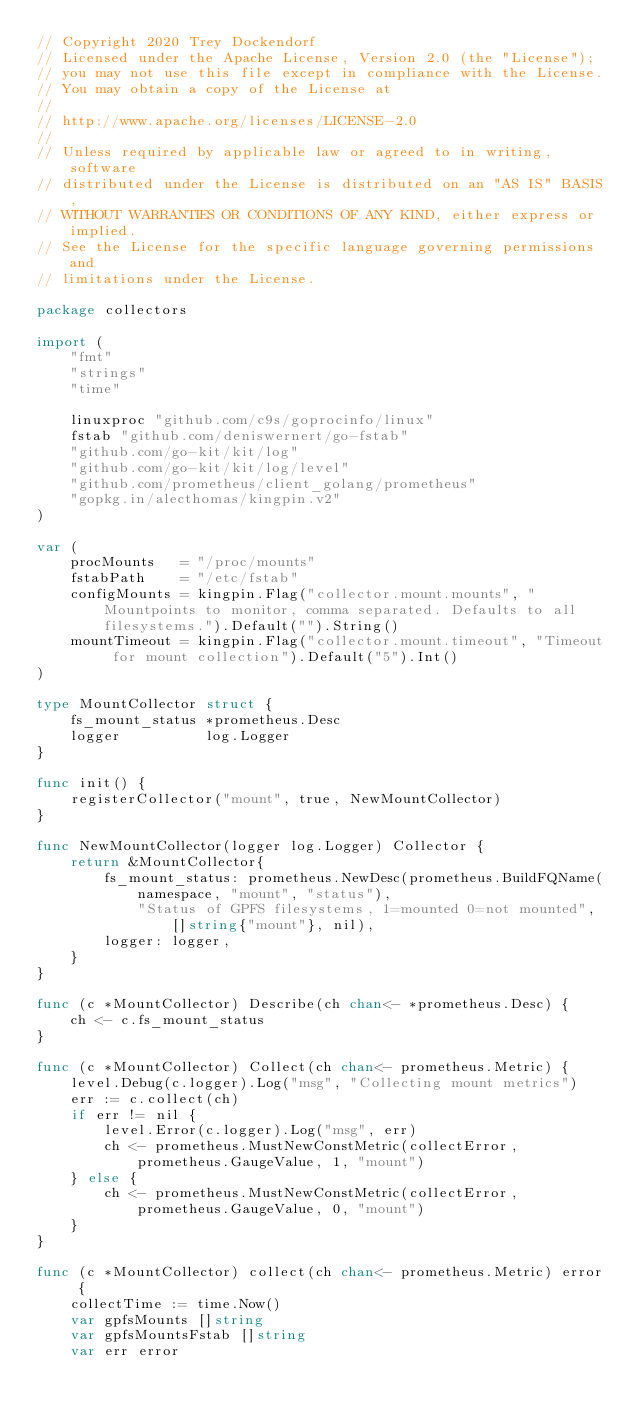Convert code to text. <code><loc_0><loc_0><loc_500><loc_500><_Go_>// Copyright 2020 Trey Dockendorf
// Licensed under the Apache License, Version 2.0 (the "License");
// you may not use this file except in compliance with the License.
// You may obtain a copy of the License at
//
// http://www.apache.org/licenses/LICENSE-2.0
//
// Unless required by applicable law or agreed to in writing, software
// distributed under the License is distributed on an "AS IS" BASIS,
// WITHOUT WARRANTIES OR CONDITIONS OF ANY KIND, either express or implied.
// See the License for the specific language governing permissions and
// limitations under the License.

package collectors

import (
	"fmt"
	"strings"
	"time"

	linuxproc "github.com/c9s/goprocinfo/linux"
	fstab "github.com/deniswernert/go-fstab"
	"github.com/go-kit/kit/log"
	"github.com/go-kit/kit/log/level"
	"github.com/prometheus/client_golang/prometheus"
	"gopkg.in/alecthomas/kingpin.v2"
)

var (
	procMounts   = "/proc/mounts"
	fstabPath    = "/etc/fstab"
	configMounts = kingpin.Flag("collector.mount.mounts", "Mountpoints to monitor, comma separated. Defaults to all filesystems.").Default("").String()
	mountTimeout = kingpin.Flag("collector.mount.timeout", "Timeout for mount collection").Default("5").Int()
)

type MountCollector struct {
	fs_mount_status *prometheus.Desc
	logger          log.Logger
}

func init() {
	registerCollector("mount", true, NewMountCollector)
}

func NewMountCollector(logger log.Logger) Collector {
	return &MountCollector{
		fs_mount_status: prometheus.NewDesc(prometheus.BuildFQName(namespace, "mount", "status"),
			"Status of GPFS filesystems, 1=mounted 0=not mounted", []string{"mount"}, nil),
		logger: logger,
	}
}

func (c *MountCollector) Describe(ch chan<- *prometheus.Desc) {
	ch <- c.fs_mount_status
}

func (c *MountCollector) Collect(ch chan<- prometheus.Metric) {
	level.Debug(c.logger).Log("msg", "Collecting mount metrics")
	err := c.collect(ch)
	if err != nil {
		level.Error(c.logger).Log("msg", err)
		ch <- prometheus.MustNewConstMetric(collectError, prometheus.GaugeValue, 1, "mount")
	} else {
		ch <- prometheus.MustNewConstMetric(collectError, prometheus.GaugeValue, 0, "mount")
	}
}

func (c *MountCollector) collect(ch chan<- prometheus.Metric) error {
	collectTime := time.Now()
	var gpfsMounts []string
	var gpfsMountsFstab []string
	var err error
</code> 